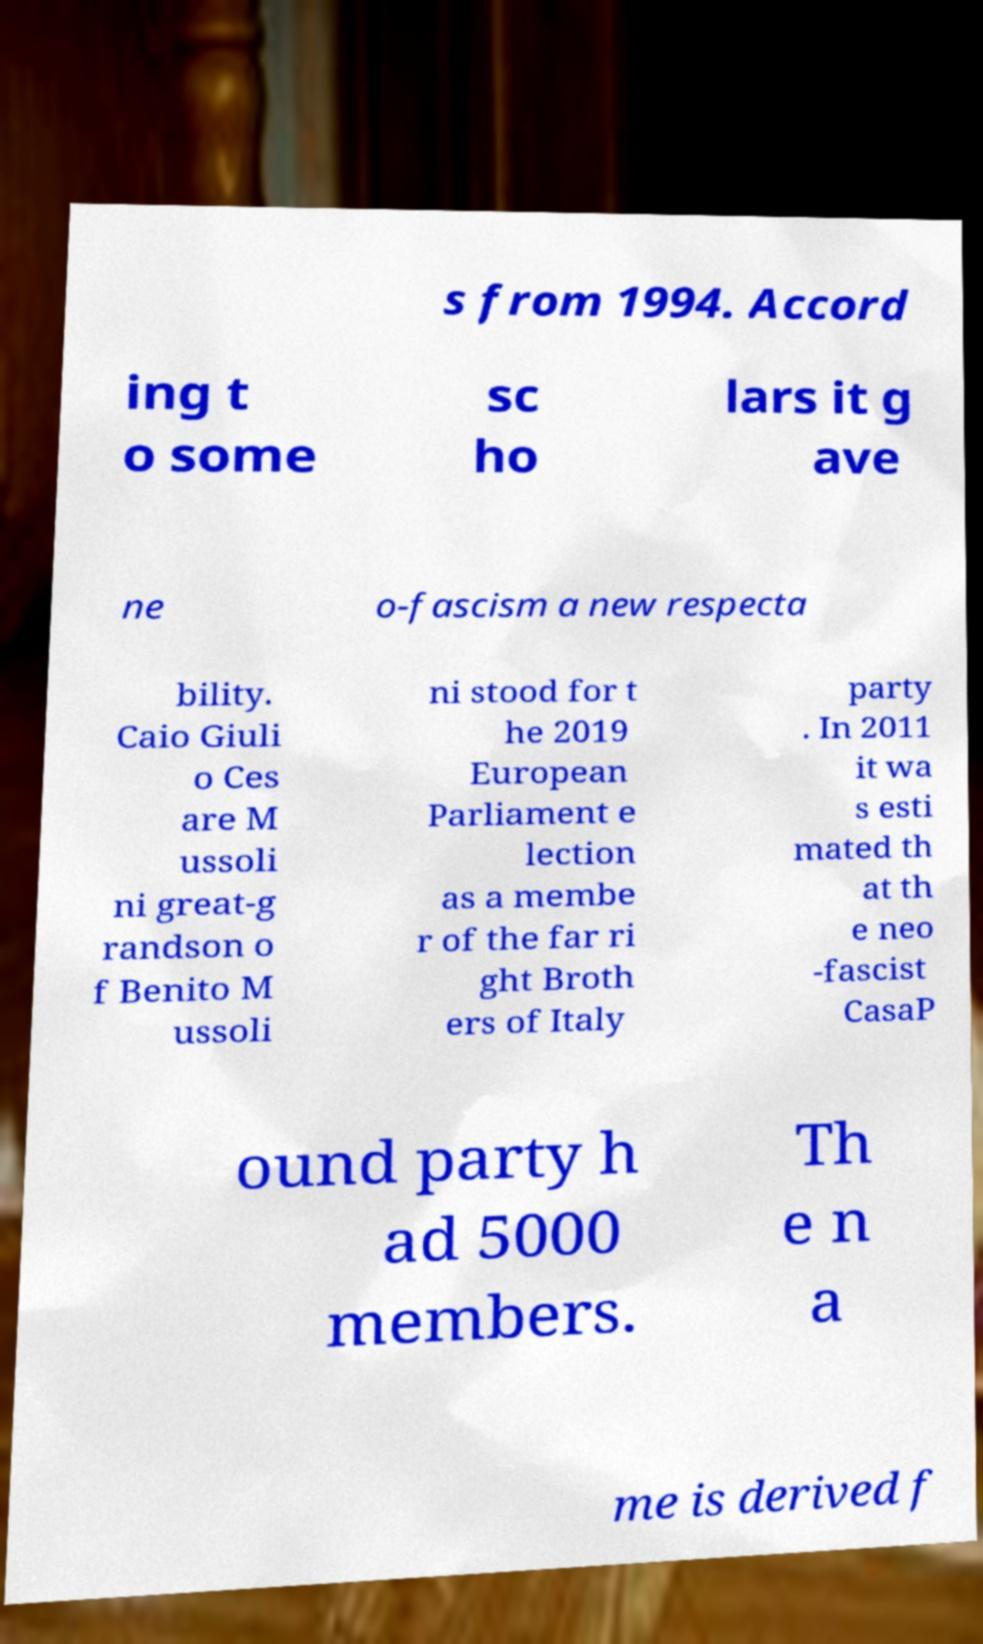Can you accurately transcribe the text from the provided image for me? s from 1994. Accord ing t o some sc ho lars it g ave ne o-fascism a new respecta bility. Caio Giuli o Ces are M ussoli ni great-g randson o f Benito M ussoli ni stood for t he 2019 European Parliament e lection as a membe r of the far ri ght Broth ers of Italy party . In 2011 it wa s esti mated th at th e neo -fascist CasaP ound party h ad 5000 members. Th e n a me is derived f 